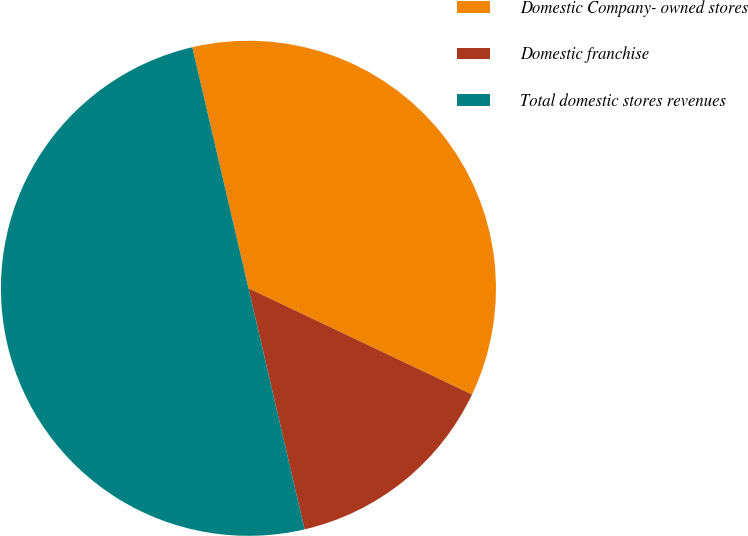Convert chart to OTSL. <chart><loc_0><loc_0><loc_500><loc_500><pie_chart><fcel>Domestic Company- owned stores<fcel>Domestic franchise<fcel>Total domestic stores revenues<nl><fcel>35.7%<fcel>14.3%<fcel>50.0%<nl></chart> 